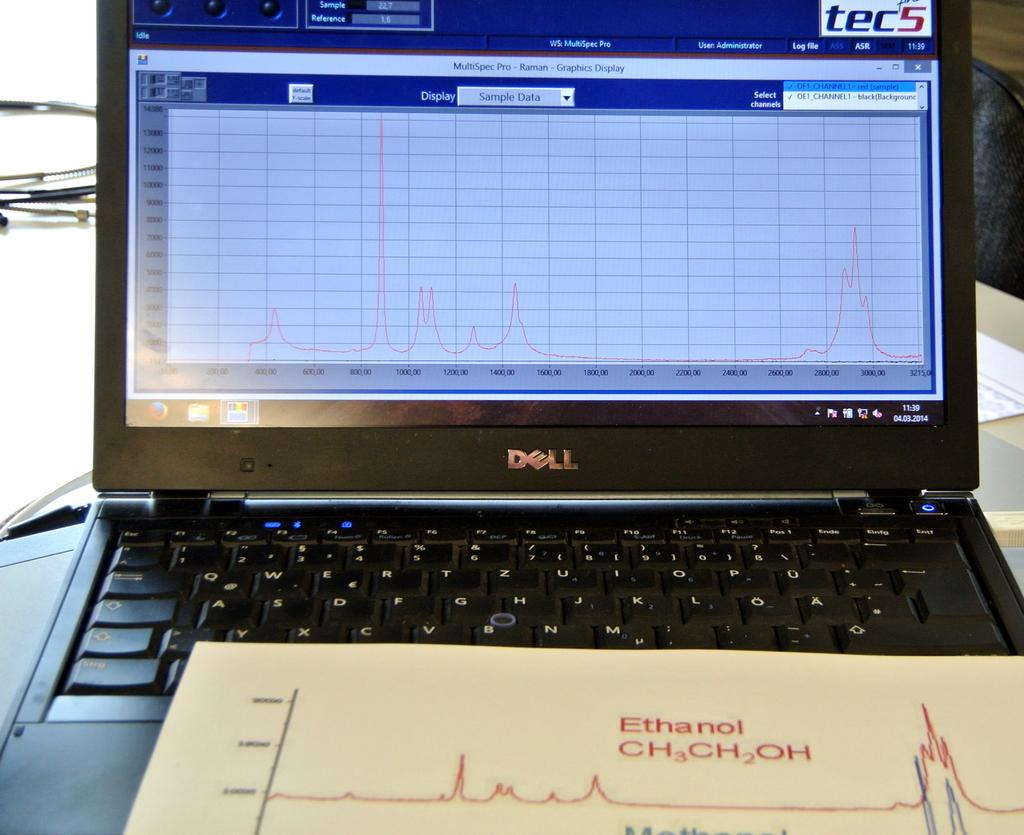Provide a one-sentence caption for the provided image. A person is studying the formula Ethanol ch3ch2oh. 